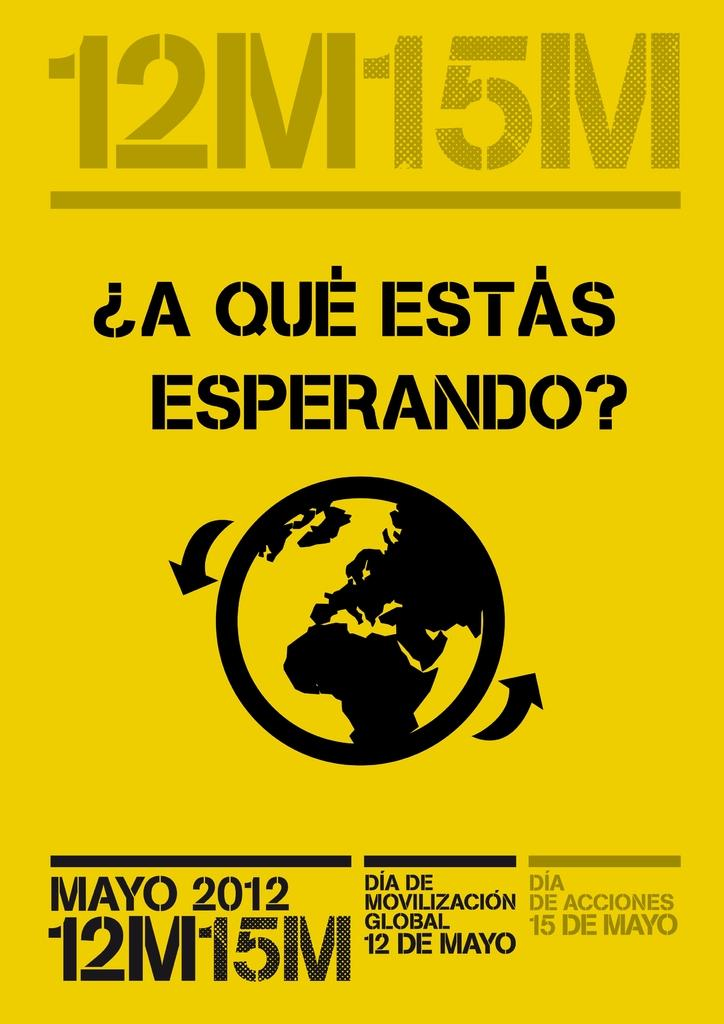<image>
Relay a brief, clear account of the picture shown. A yellow 12M15M flyer offers information about the earth. 